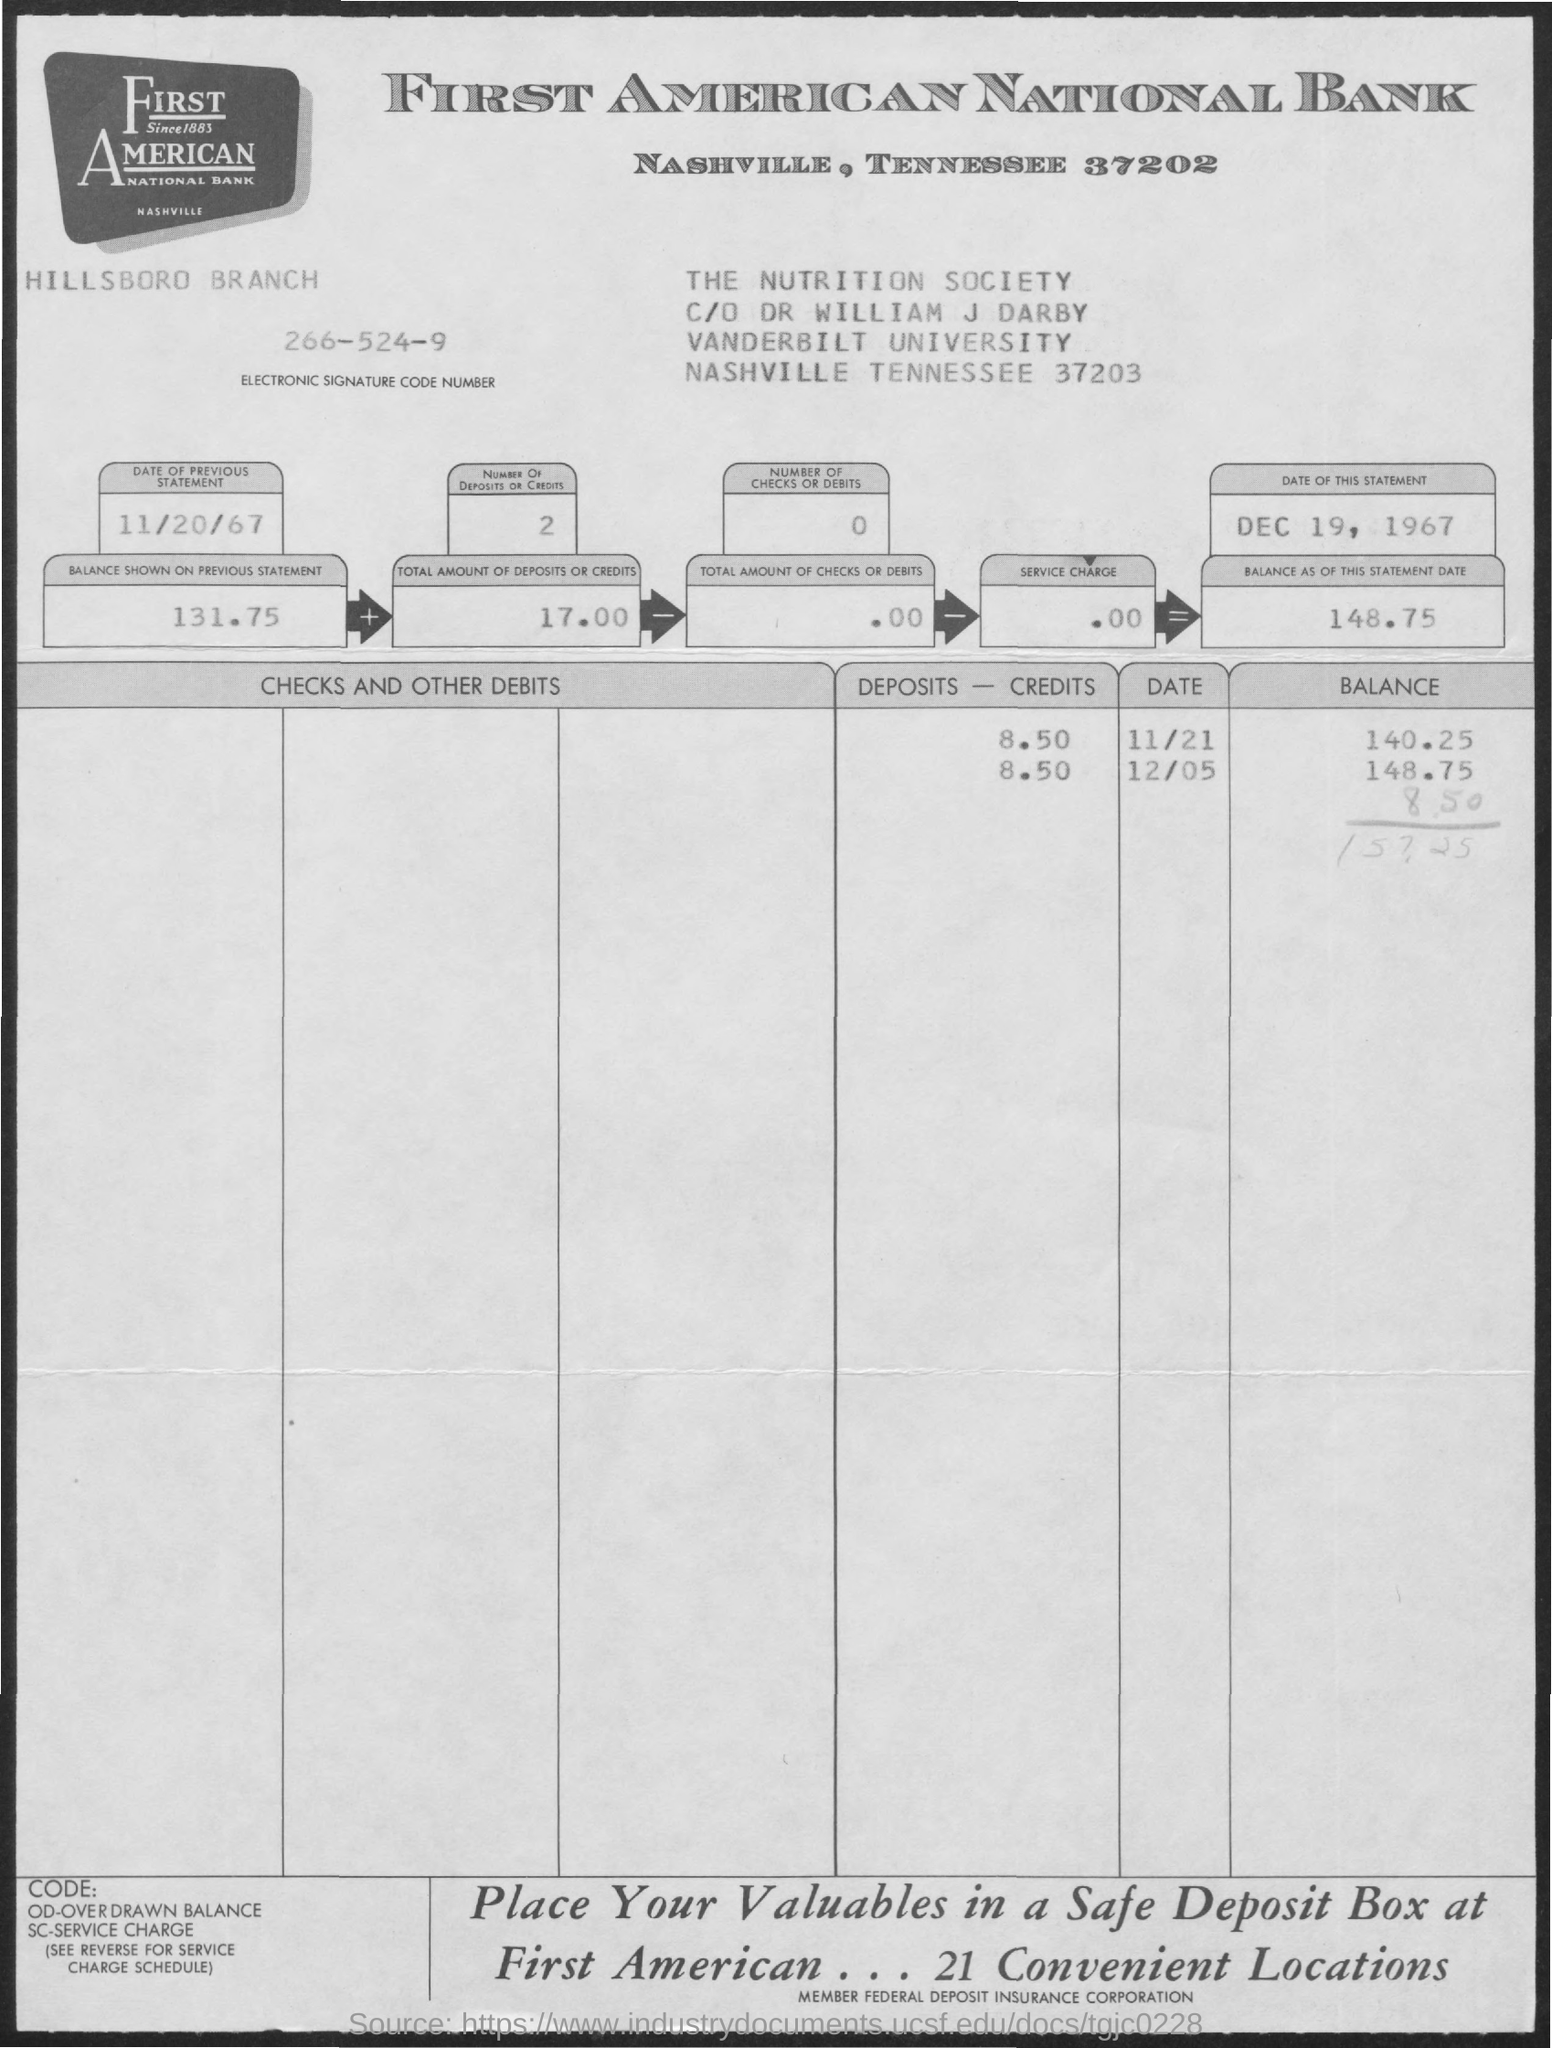Give some essential details in this illustration. The total number of deposits/credits is 2. The electronic signature code number is 266-524-9... The service charge is $0.00. The total number of checks or debits is 0 or less. The total amount of checks or debits is equal to zero. 